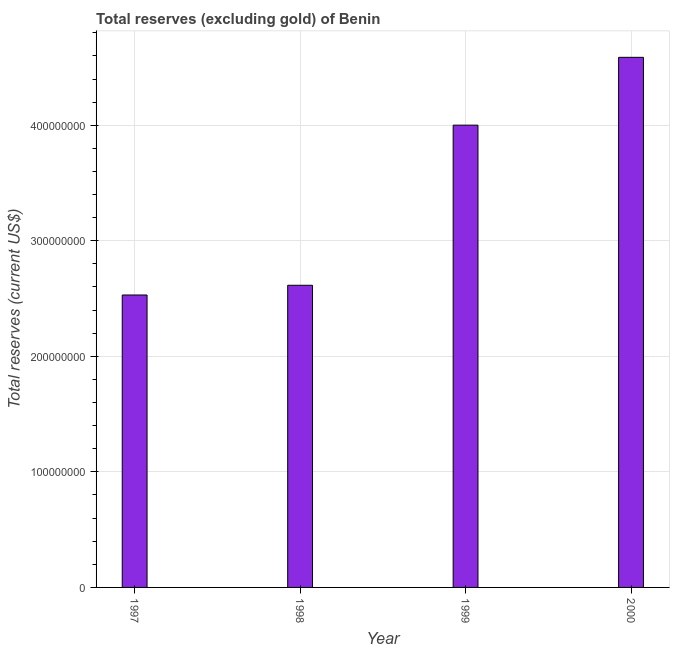Does the graph contain any zero values?
Offer a terse response. No. Does the graph contain grids?
Provide a short and direct response. Yes. What is the title of the graph?
Keep it short and to the point. Total reserves (excluding gold) of Benin. What is the label or title of the X-axis?
Give a very brief answer. Year. What is the label or title of the Y-axis?
Offer a terse response. Total reserves (current US$). What is the total reserves (excluding gold) in 1999?
Provide a short and direct response. 4.00e+08. Across all years, what is the maximum total reserves (excluding gold)?
Your response must be concise. 4.59e+08. Across all years, what is the minimum total reserves (excluding gold)?
Offer a very short reply. 2.53e+08. In which year was the total reserves (excluding gold) minimum?
Keep it short and to the point. 1997. What is the sum of the total reserves (excluding gold)?
Your answer should be very brief. 1.37e+09. What is the difference between the total reserves (excluding gold) in 1998 and 2000?
Ensure brevity in your answer.  -1.97e+08. What is the average total reserves (excluding gold) per year?
Offer a terse response. 3.43e+08. What is the median total reserves (excluding gold)?
Ensure brevity in your answer.  3.31e+08. Is the total reserves (excluding gold) in 1997 less than that in 1999?
Your answer should be very brief. Yes. What is the difference between the highest and the second highest total reserves (excluding gold)?
Keep it short and to the point. 5.87e+07. Is the sum of the total reserves (excluding gold) in 1998 and 2000 greater than the maximum total reserves (excluding gold) across all years?
Give a very brief answer. Yes. What is the difference between the highest and the lowest total reserves (excluding gold)?
Keep it short and to the point. 2.06e+08. In how many years, is the total reserves (excluding gold) greater than the average total reserves (excluding gold) taken over all years?
Make the answer very short. 2. How many bars are there?
Provide a succinct answer. 4. Are all the bars in the graph horizontal?
Your answer should be compact. No. How many years are there in the graph?
Your response must be concise. 4. What is the Total reserves (current US$) in 1997?
Your response must be concise. 2.53e+08. What is the Total reserves (current US$) of 1998?
Your answer should be compact. 2.61e+08. What is the Total reserves (current US$) of 1999?
Offer a terse response. 4.00e+08. What is the Total reserves (current US$) of 2000?
Offer a terse response. 4.59e+08. What is the difference between the Total reserves (current US$) in 1997 and 1998?
Make the answer very short. -8.41e+06. What is the difference between the Total reserves (current US$) in 1997 and 1999?
Your response must be concise. -1.47e+08. What is the difference between the Total reserves (current US$) in 1997 and 2000?
Make the answer very short. -2.06e+08. What is the difference between the Total reserves (current US$) in 1998 and 1999?
Make the answer very short. -1.39e+08. What is the difference between the Total reserves (current US$) in 1998 and 2000?
Provide a succinct answer. -1.97e+08. What is the difference between the Total reserves (current US$) in 1999 and 2000?
Make the answer very short. -5.87e+07. What is the ratio of the Total reserves (current US$) in 1997 to that in 1998?
Your response must be concise. 0.97. What is the ratio of the Total reserves (current US$) in 1997 to that in 1999?
Your answer should be compact. 0.63. What is the ratio of the Total reserves (current US$) in 1997 to that in 2000?
Provide a succinct answer. 0.55. What is the ratio of the Total reserves (current US$) in 1998 to that in 1999?
Provide a short and direct response. 0.65. What is the ratio of the Total reserves (current US$) in 1998 to that in 2000?
Offer a terse response. 0.57. What is the ratio of the Total reserves (current US$) in 1999 to that in 2000?
Offer a very short reply. 0.87. 